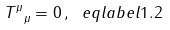Convert formula to latex. <formula><loc_0><loc_0><loc_500><loc_500>T ^ { \mu } _ { \ \mu } = 0 \, , \ e q l a b e l { 1 . 2 }</formula> 